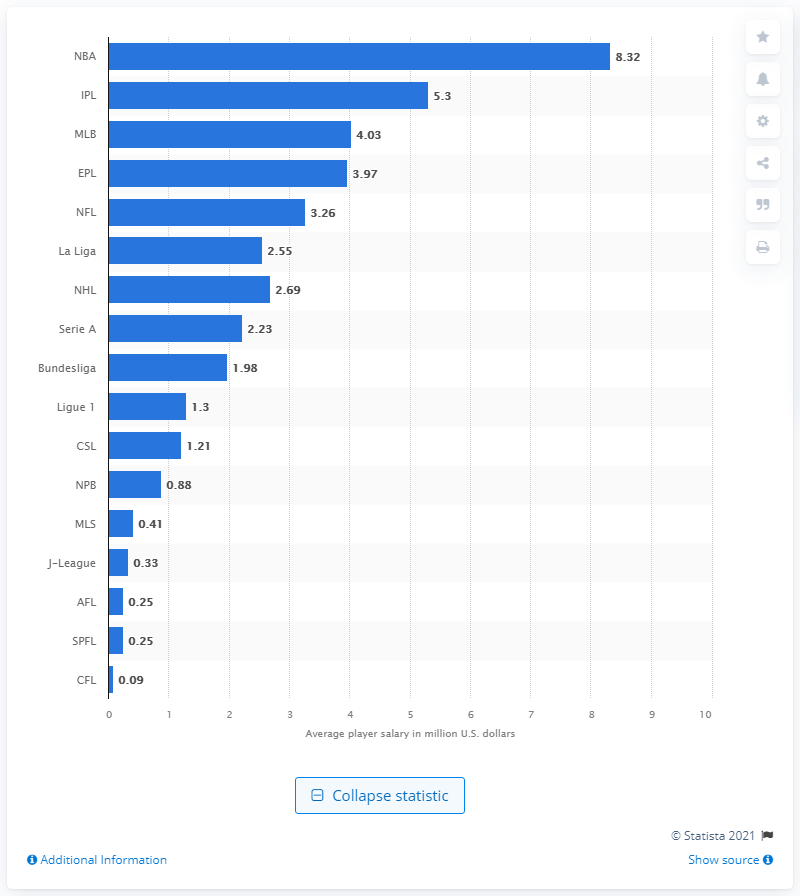Outline some significant characteristics in this image. NBA players earn an average of $8.32 million per year in salary and endorsements. 